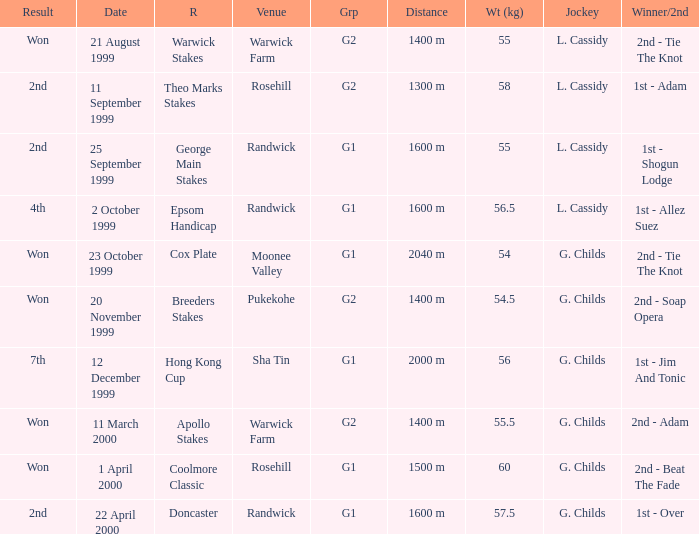List the weight for 56.5 kilograms. Epsom Handicap. 